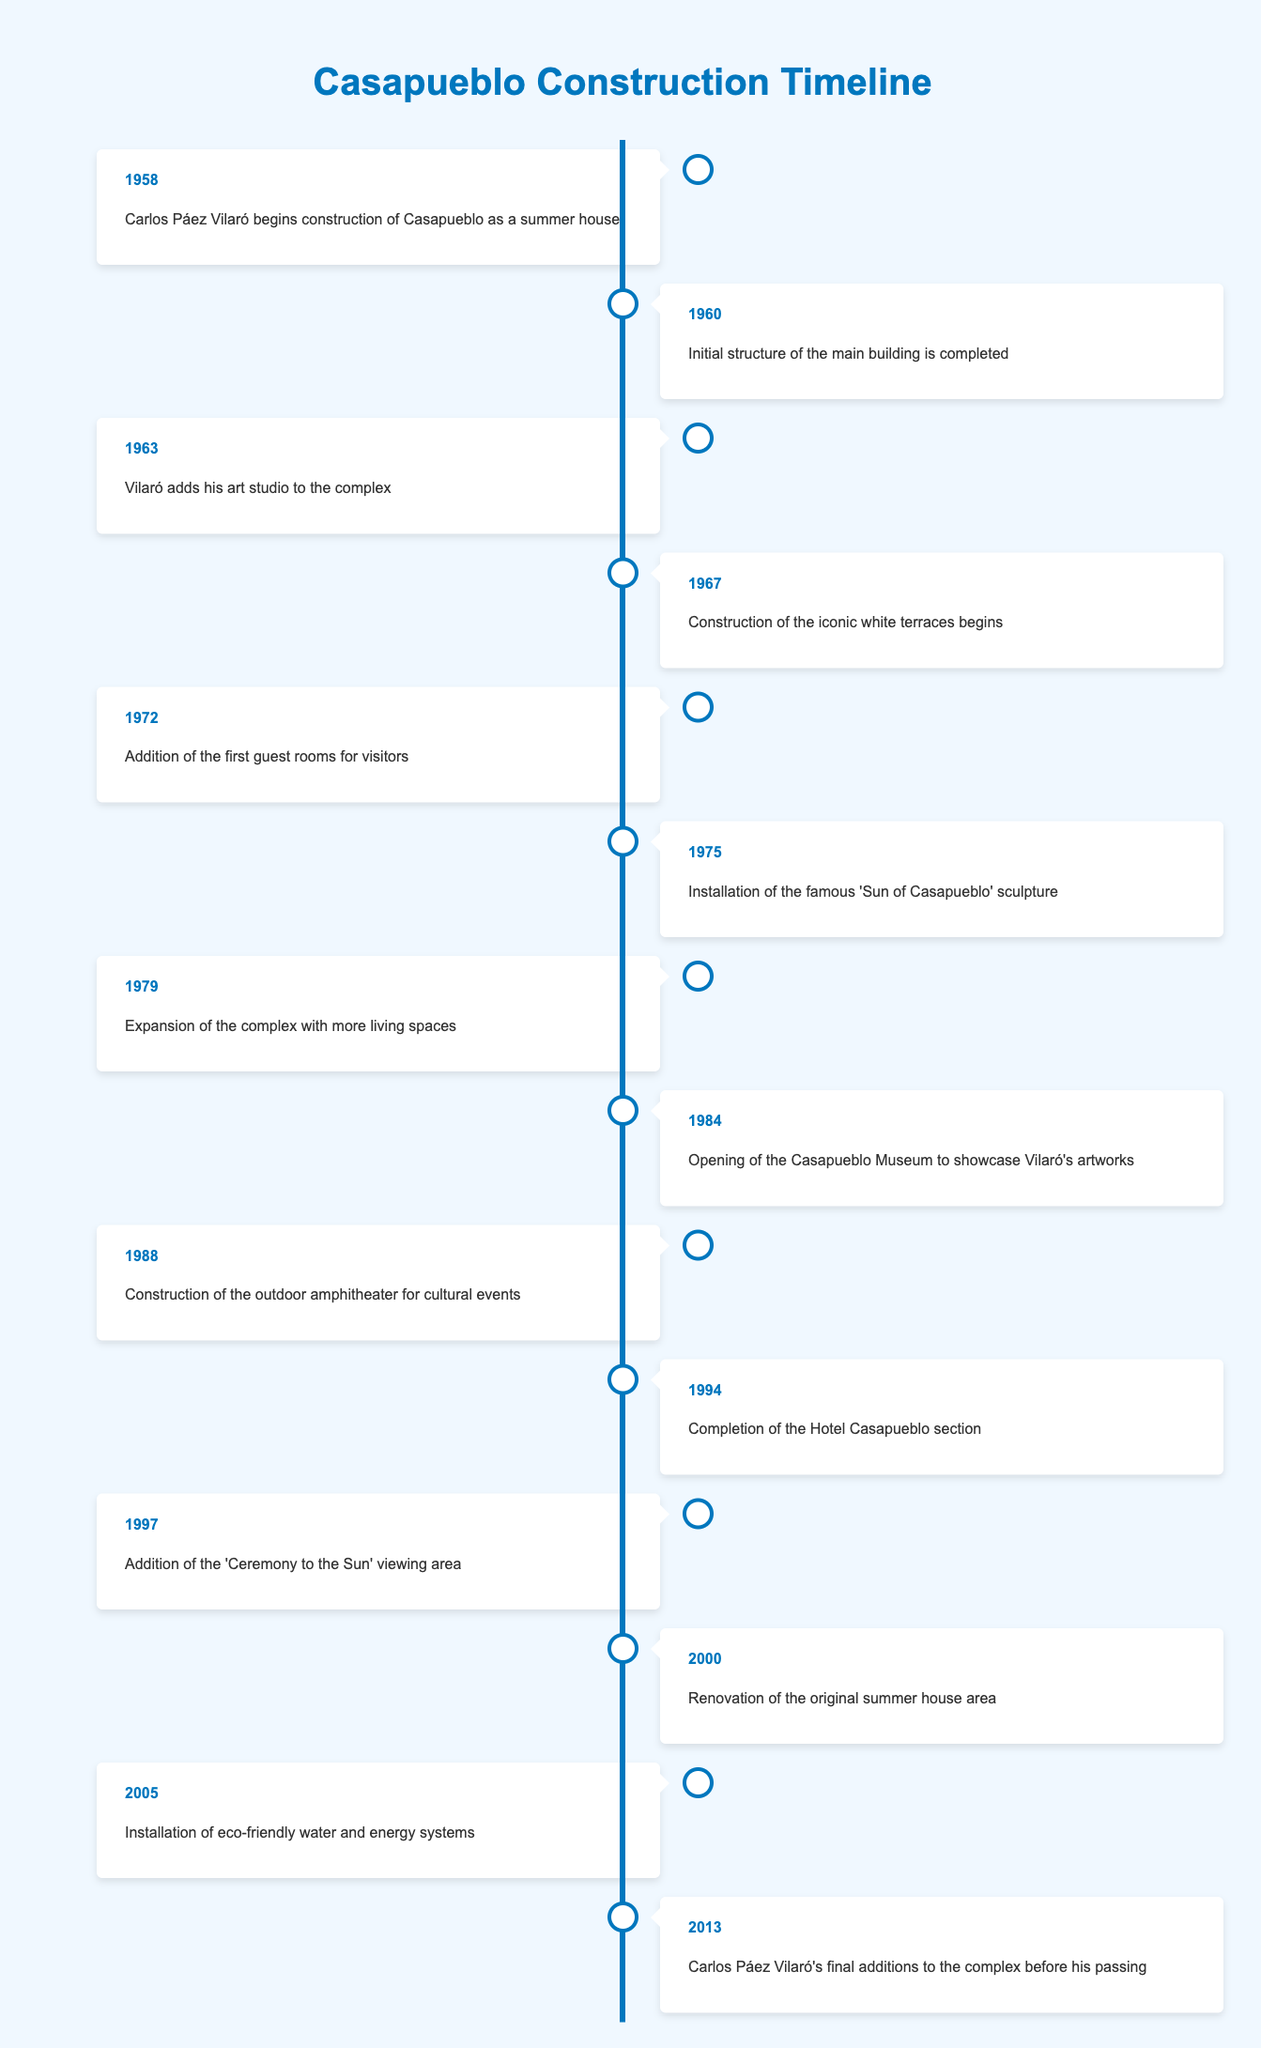What year did Carlos Páez Vilaró begin construction of Casapueblo? According to the timeline, the event stating that Carlos Páez Vilaró begins construction of Casapueblo as a summer house is listed under the year 1958.
Answer: 1958 What significant addition was made to Casapueblo in 1963? The timeline mentions that in 1963, Vilaró adds his art studio to the complex.
Answer: Vilaró adds his art studio How many years passed between the completion of the Hotel Casapueblo section in 1994 and the installation of eco-friendly systems in 2005? By calculating the difference between 2005 and 1994, we find 2005 - 1994 = 11 years.
Answer: 11 years Was the outdoor amphitheater constructed before or after the Casapueblo Museum opened? The timeline indicates that the Casapueblo Museum opened in 1984 and the outdoor amphitheater was constructed in 1988, thus the amphitheater was built after the museum.
Answer: After What year saw both the addition of guest rooms and the installation of the 'Sun of Casapueblo' sculpture? The timeline shows that the addition of the first guest rooms occurred in 1972 and the installation of the sculpture was in 1975, so these events did not happen in the same year.
Answer: No, not the same year How many events occurred in the 1980s? By reviewing the timeline, we count four events: the opening of the museum in 1984, the amphitheater construction in 1988, and the completion of two other key events in this decade, totaling four distinct events.
Answer: 4 events Which event happened last in the construction timeline? According to the timeline, the last listed event is Carlos Páez Vilaró's final additions to the complex before his passing, which occurred in 2013.
Answer: 2013 What is the first major construction phase mentioned in the timeline? The first major event in the timeline is in 1958 when Carlos Páez Vilaró begins construction of Casapueblo as a summer house.
Answer: Beginning construction as a summer house How many years were there between the start of construction and the installation of eco-friendly systems? The starting year of construction is 1958 and the installation of eco-friendly systems took place in 2005. Thus, calculating the difference gives us 2005 - 1958 = 47 years.
Answer: 47 years Which year marks the completion of the initial structure of the main building? The timeline states that the initial structure of the main building was completed in 1960.
Answer: 1960 